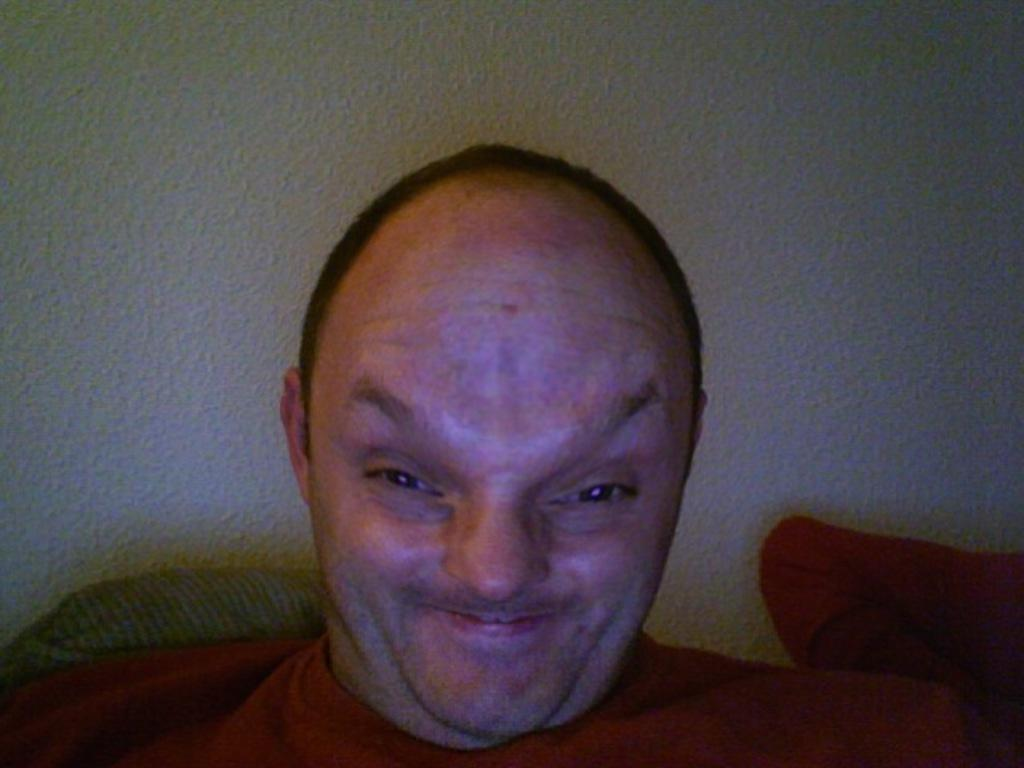Where was the image taken? The image is taken indoors. What can be seen in the background of the image? There is a wall in the background of the image. Who is the main subject in the image? There is a man in the middle of the image. How would you describe the man's facial expression? The man has a weird face. What type of guitar can be seen in the image? There is no guitar present in the image. What land or range is visible in the image? The image is taken indoors, so there is no land or range visible. 